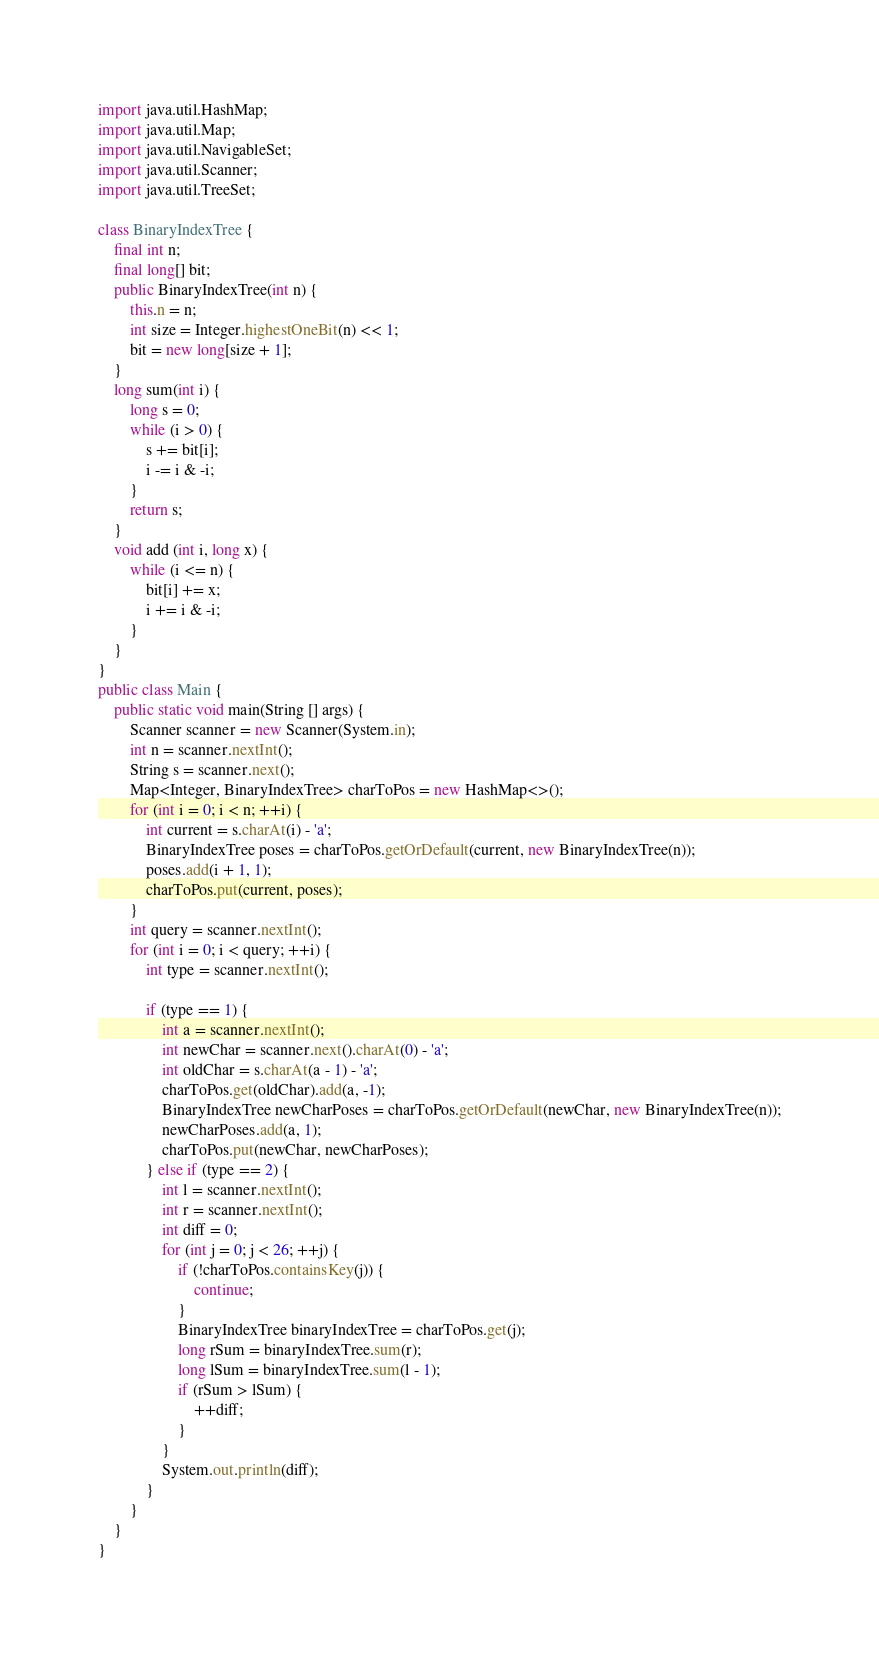Convert code to text. <code><loc_0><loc_0><loc_500><loc_500><_Java_>
import java.util.HashMap;
import java.util.Map;
import java.util.NavigableSet;
import java.util.Scanner;
import java.util.TreeSet;

class BinaryIndexTree {
    final int n;
    final long[] bit;
    public BinaryIndexTree(int n) {
        this.n = n;
        int size = Integer.highestOneBit(n) << 1;
        bit = new long[size + 1];
    }
    long sum(int i) {
        long s = 0;
        while (i > 0) {
            s += bit[i];
            i -= i & -i;
        }
        return s;
    }
    void add (int i, long x) {
        while (i <= n) {
            bit[i] += x;
            i += i & -i;
        }
    }
}
public class Main {
    public static void main(String [] args) {
        Scanner scanner = new Scanner(System.in);
        int n = scanner.nextInt();
        String s = scanner.next();
        Map<Integer, BinaryIndexTree> charToPos = new HashMap<>();
        for (int i = 0; i < n; ++i) {
            int current = s.charAt(i) - 'a';
            BinaryIndexTree poses = charToPos.getOrDefault(current, new BinaryIndexTree(n));
            poses.add(i + 1, 1);
            charToPos.put(current, poses);
        }
        int query = scanner.nextInt();
        for (int i = 0; i < query; ++i) {
            int type = scanner.nextInt();

            if (type == 1) {
                int a = scanner.nextInt();
                int newChar = scanner.next().charAt(0) - 'a';
                int oldChar = s.charAt(a - 1) - 'a';
                charToPos.get(oldChar).add(a, -1);
                BinaryIndexTree newCharPoses = charToPos.getOrDefault(newChar, new BinaryIndexTree(n));
                newCharPoses.add(a, 1);
                charToPos.put(newChar, newCharPoses);
            } else if (type == 2) {
                int l = scanner.nextInt();
                int r = scanner.nextInt();
                int diff = 0;
                for (int j = 0; j < 26; ++j) {
                    if (!charToPos.containsKey(j)) {
                        continue;
                    }
                    BinaryIndexTree binaryIndexTree = charToPos.get(j);
                    long rSum = binaryIndexTree.sum(r);
                    long lSum = binaryIndexTree.sum(l - 1);
                    if (rSum > lSum) {
                        ++diff;
                    }
                }
                System.out.println(diff);
            }
        }
    }
}
</code> 